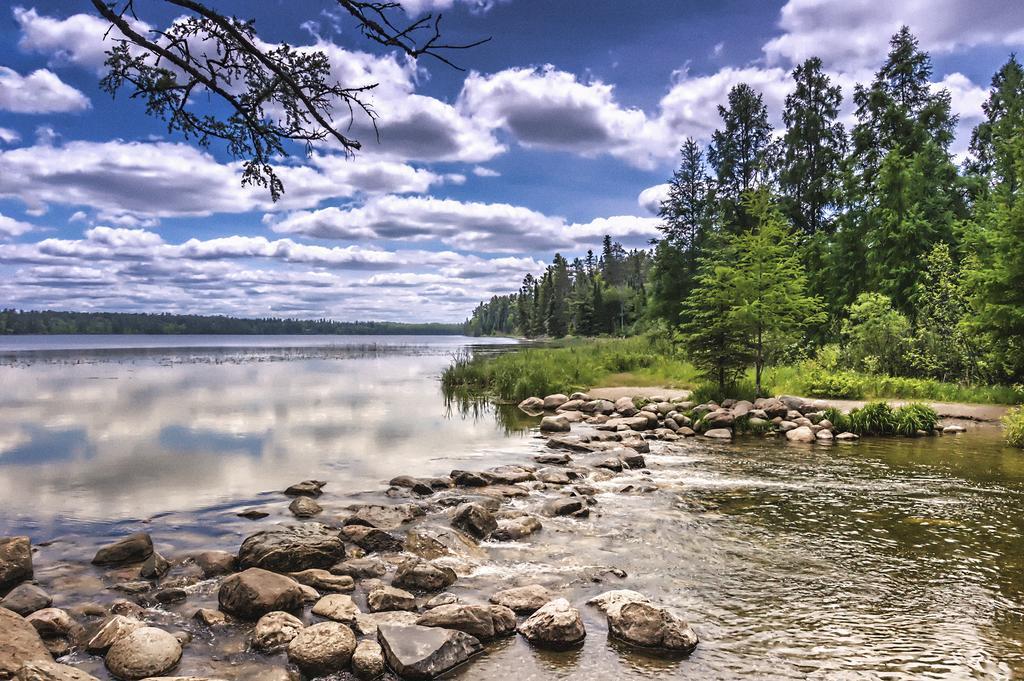Could you give a brief overview of what you see in this image? At the bottom of the image there is water and there are some stones. In the middle of the image there are some trees. At the top of the image there are some clouds and sky. 